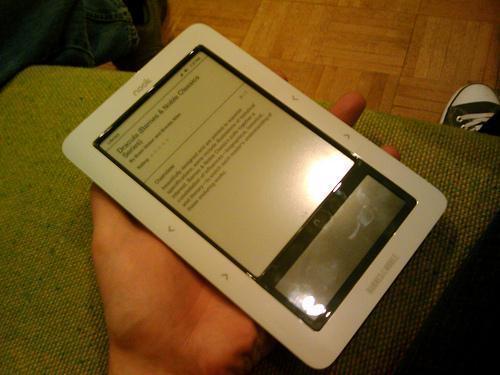How many devices are in the picture?
Give a very brief answer. 1. 